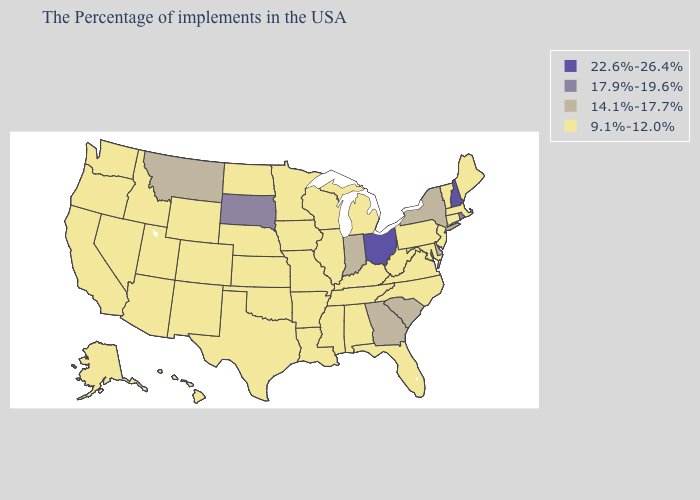Name the states that have a value in the range 22.6%-26.4%?
Answer briefly. New Hampshire, Ohio. Name the states that have a value in the range 9.1%-12.0%?
Write a very short answer. Maine, Massachusetts, Vermont, Connecticut, New Jersey, Maryland, Pennsylvania, Virginia, North Carolina, West Virginia, Florida, Michigan, Kentucky, Alabama, Tennessee, Wisconsin, Illinois, Mississippi, Louisiana, Missouri, Arkansas, Minnesota, Iowa, Kansas, Nebraska, Oklahoma, Texas, North Dakota, Wyoming, Colorado, New Mexico, Utah, Arizona, Idaho, Nevada, California, Washington, Oregon, Alaska, Hawaii. What is the value of Wisconsin?
Write a very short answer. 9.1%-12.0%. What is the value of Alabama?
Give a very brief answer. 9.1%-12.0%. What is the value of Arizona?
Keep it brief. 9.1%-12.0%. Does the first symbol in the legend represent the smallest category?
Write a very short answer. No. Does Georgia have the highest value in the South?
Concise answer only. Yes. Name the states that have a value in the range 9.1%-12.0%?
Be succinct. Maine, Massachusetts, Vermont, Connecticut, New Jersey, Maryland, Pennsylvania, Virginia, North Carolina, West Virginia, Florida, Michigan, Kentucky, Alabama, Tennessee, Wisconsin, Illinois, Mississippi, Louisiana, Missouri, Arkansas, Minnesota, Iowa, Kansas, Nebraska, Oklahoma, Texas, North Dakota, Wyoming, Colorado, New Mexico, Utah, Arizona, Idaho, Nevada, California, Washington, Oregon, Alaska, Hawaii. What is the lowest value in states that border Ohio?
Write a very short answer. 9.1%-12.0%. Does California have a higher value than New Jersey?
Concise answer only. No. Name the states that have a value in the range 22.6%-26.4%?
Quick response, please. New Hampshire, Ohio. Name the states that have a value in the range 14.1%-17.7%?
Be succinct. New York, Delaware, South Carolina, Georgia, Indiana, Montana. Name the states that have a value in the range 9.1%-12.0%?
Answer briefly. Maine, Massachusetts, Vermont, Connecticut, New Jersey, Maryland, Pennsylvania, Virginia, North Carolina, West Virginia, Florida, Michigan, Kentucky, Alabama, Tennessee, Wisconsin, Illinois, Mississippi, Louisiana, Missouri, Arkansas, Minnesota, Iowa, Kansas, Nebraska, Oklahoma, Texas, North Dakota, Wyoming, Colorado, New Mexico, Utah, Arizona, Idaho, Nevada, California, Washington, Oregon, Alaska, Hawaii. What is the value of New Jersey?
Answer briefly. 9.1%-12.0%. What is the value of Colorado?
Answer briefly. 9.1%-12.0%. 